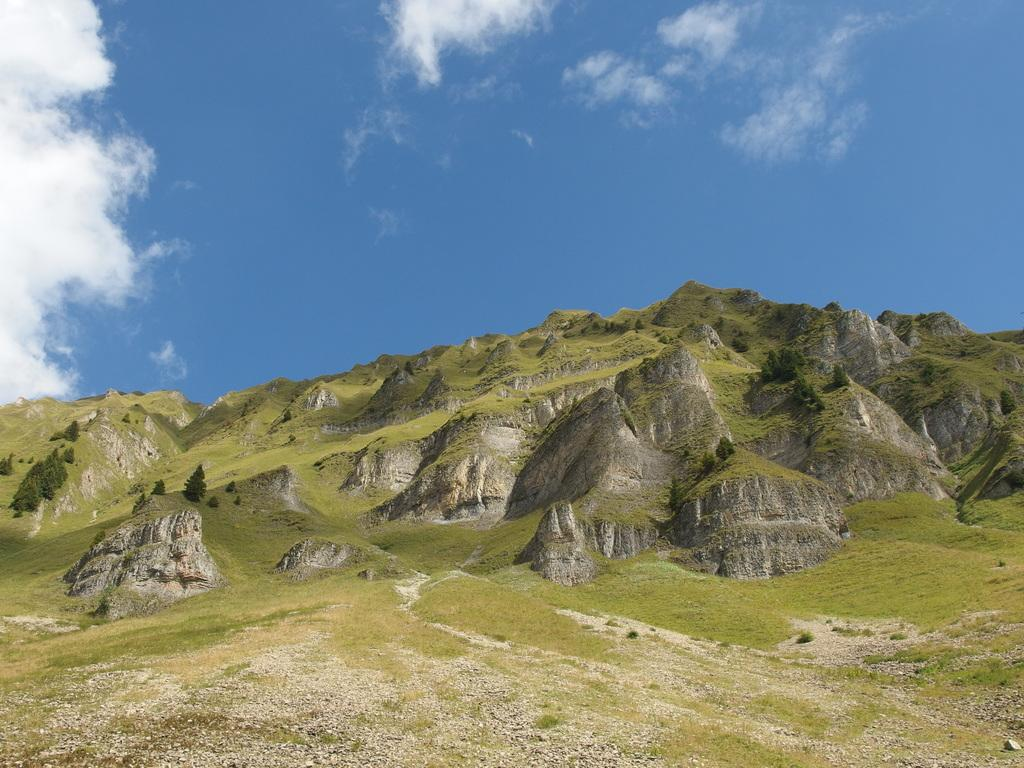What type of vegetation can be seen on the hills in the image? There are trees on the hills in the image. What else can be seen on the hills besides trees? There is grass on the hills in the image. What is visible at the top of the image? The sky is visible at the top of the image. What rhythm is the self-playing piano producing in the image? There is no self-playing piano present in the image. What time of day is it in the image, considering the afternoon? The time of day cannot be determined from the image alone, as there are no specific clues or indicators of time. 